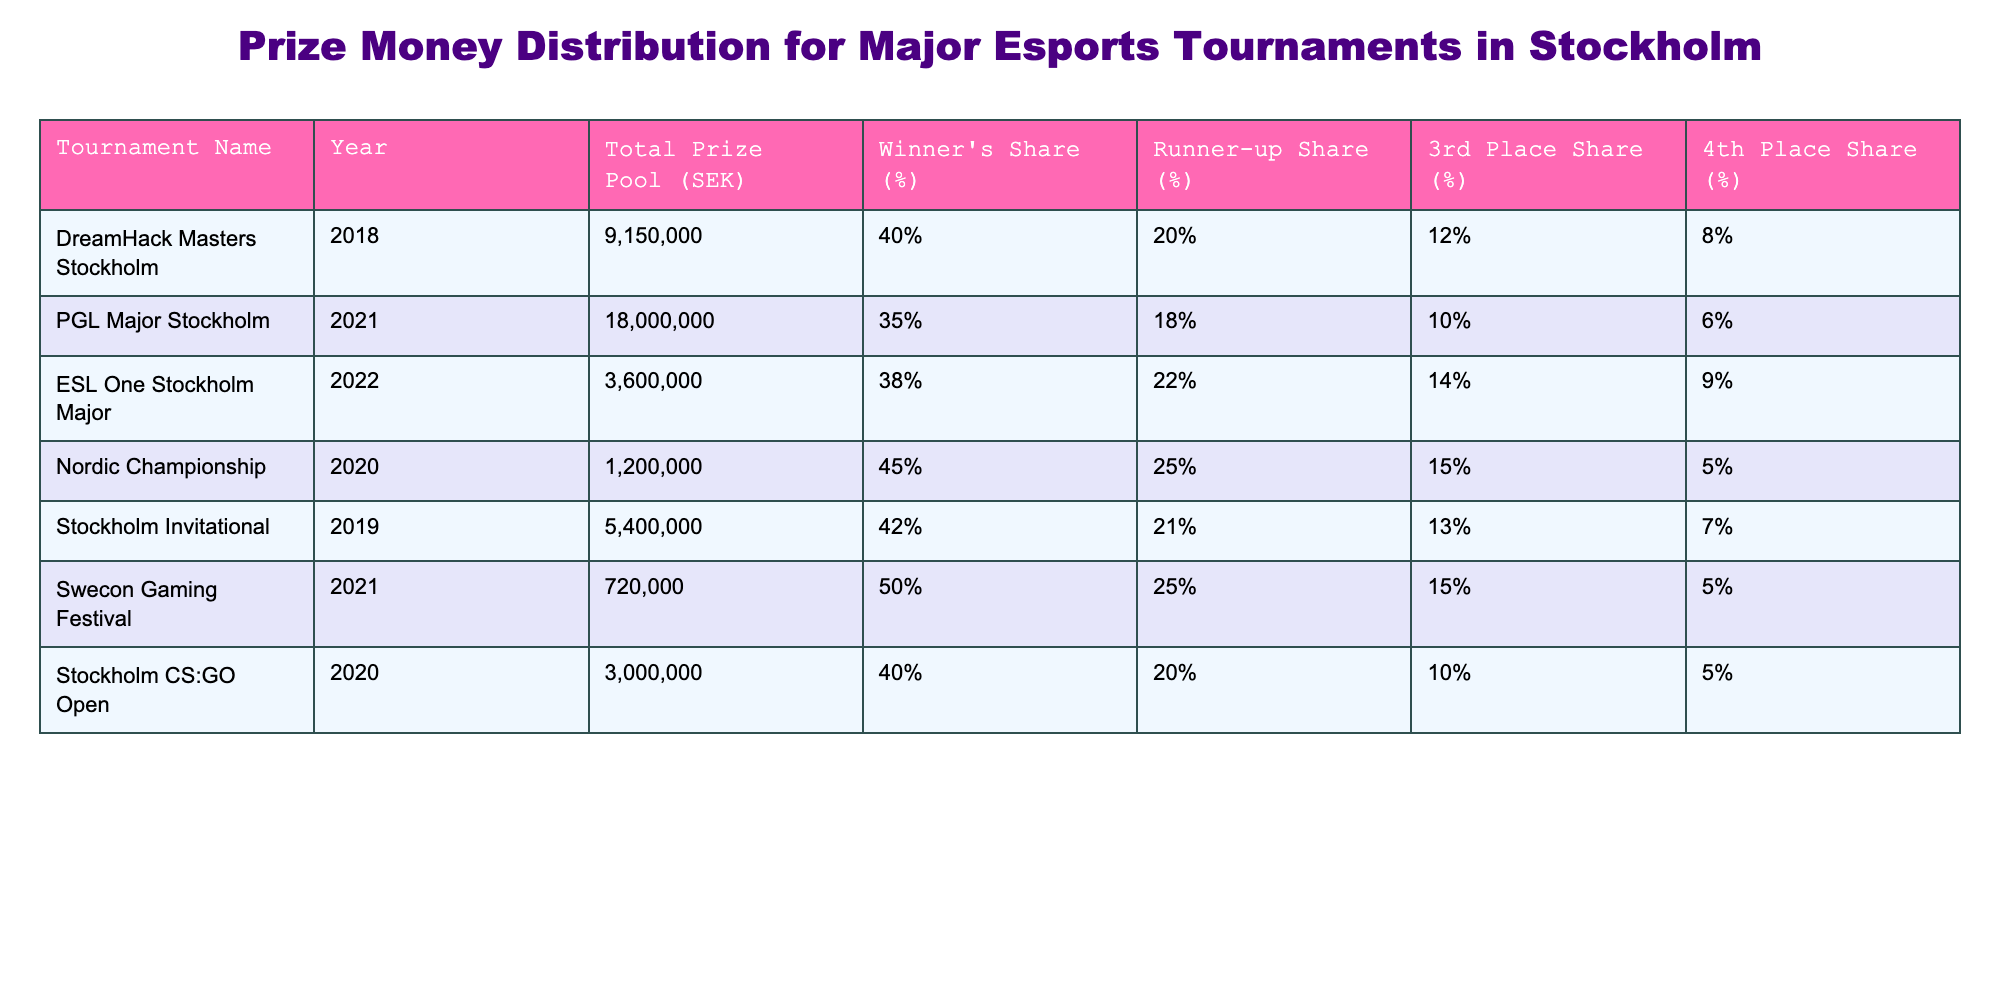What is the total prize pool for the PGL Major Stockholm in 2021? The table shows that the total prize pool for the PGL Major Stockholm in 2021 is listed under the "Total Prize Pool (SEK)" column. It states 18,000,000 SEK.
Answer: 18,000,000 SEK Which tournament had the highest winner's share percentage? By comparing the "Winner's Share (%)" column for each tournament, the Nordic Championship in 2020 has the highest winner's share at 45%.
Answer: Nordic Championship (2020), 45% What is the runner-up share for the ESL One Stockholm Major in 2022? The table provides the runner-up share percentage for each tournament, and for ESL One Stockholm Major in 2022, it is 22%.
Answer: 22% If you sum up the total prize pools of the DreamHack Masters Stockholm and Stockholm CS:GO Open, what is the result? The total prize pool for DreamHack Masters Stockholm is 9,150,000 SEK and for Stockholm CS:GO Open, it is 3,000,000 SEK. Adding these values gives: 9,150,000 + 3,000,000 = 12,150,000 SEK.
Answer: 12,150,000 SEK Is the runner-up share for the Stockholm Invitational higher than that of the Swecon Gaming Festival? The runner-up share for the Stockholm Invitational is 21%, and for the Swecon Gaming Festival, it is 25%. Since 21% is less than 25%, the statement is false.
Answer: No What percentage of the total prize pool does the third place receive in the 2021 PGL Major Stockholm? The third place share for the PGL Major Stockholm is found in the corresponding column, which shows a share of 10%.
Answer: 10% What is the average winner's share percentage across all tournaments listed? The winner's share percentages are: 40, 35, 38, 45, 42, 50, 40. Summing these gives 40 + 35 + 38 + 45 + 42 + 50 + 40 = 290. There are 7 tournaments, so the average is 290 / 7 = 41.43%.
Answer: 41.43% Which tournament had the lowest total prize pool? Looking at the "Total Prize Pool (SEK)" column, the lowest value listed is 720,000 SEK from the Swecon Gaming Festival.
Answer: Swecon Gaming Festival (2021) Does the 4th place share for ESL One Stockholm Major exceed the 4th place share for the DreamHack Masters Stockholm? The 4th place share for ESL One is 9% and for DreamHack Masters it is 8%. Since 9% is greater than 8%, the statement is true.
Answer: Yes How much more did the winner of the PGL Major Stockholm receive compared to the winner of the Nordic Championship? The winner's share for PGL Major Stockholm is 35% of 18,000,000 SEK, equating to 6,300,000 SEK. For the Nordic Championship, the winner's share is 45% of 1,200,000 SEK, equating to 540,000 SEK. The difference is 6,300,000 - 540,000 = 5,760,000 SEK.
Answer: 5,760,000 SEK 